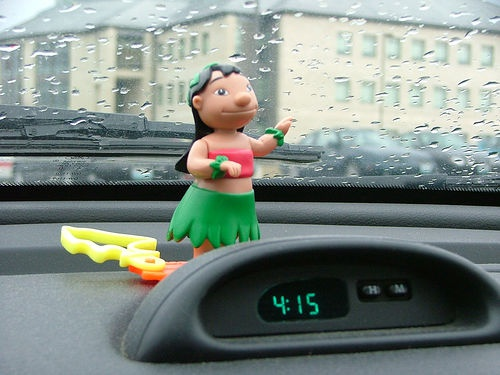Describe the objects in this image and their specific colors. I can see car in lightgray, darkgray, lightblue, and gray tones and clock in lightgray, black, teal, and turquoise tones in this image. 